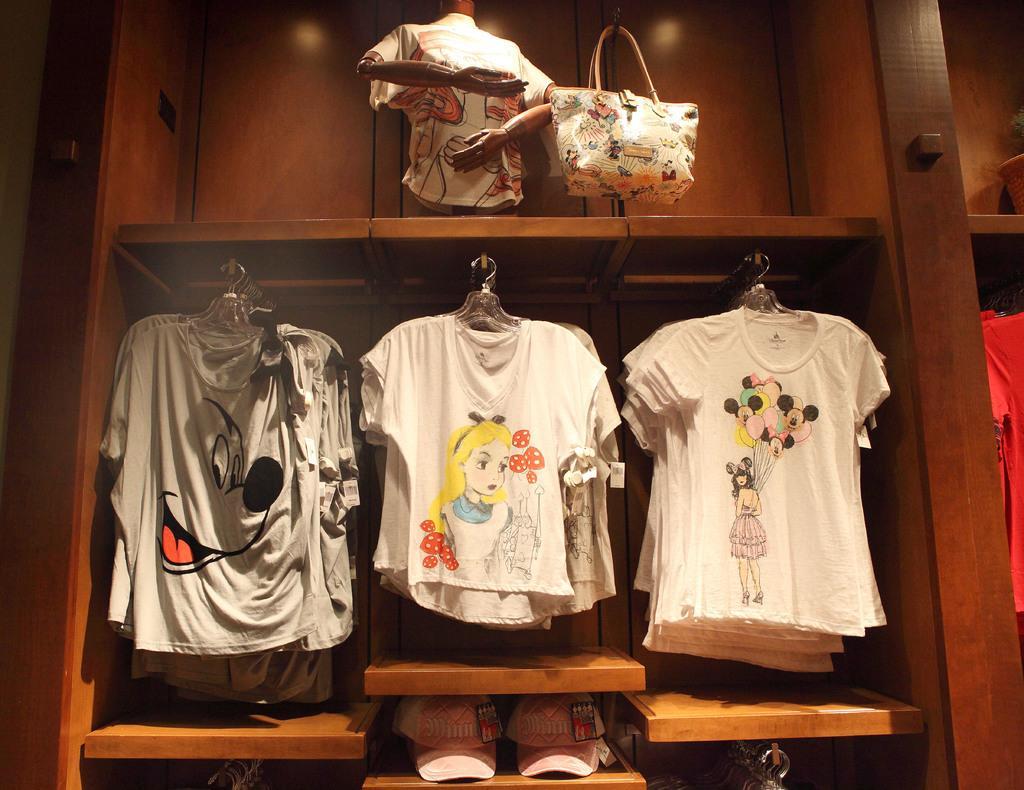In one or two sentences, can you explain what this image depicts? This is a picture taken in a room, there are the clothes hanging to the shelf. The clothes are in the wooden shelf. 